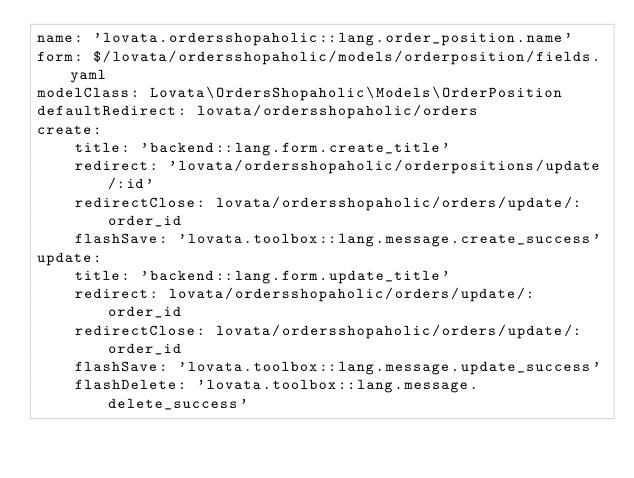Convert code to text. <code><loc_0><loc_0><loc_500><loc_500><_YAML_>name: 'lovata.ordersshopaholic::lang.order_position.name'
form: $/lovata/ordersshopaholic/models/orderposition/fields.yaml
modelClass: Lovata\OrdersShopaholic\Models\OrderPosition
defaultRedirect: lovata/ordersshopaholic/orders
create:
    title: 'backend::lang.form.create_title'
    redirect: 'lovata/ordersshopaholic/orderpositions/update/:id'
    redirectClose: lovata/ordersshopaholic/orders/update/:order_id
    flashSave: 'lovata.toolbox::lang.message.create_success'
update:
    title: 'backend::lang.form.update_title'
    redirect: lovata/ordersshopaholic/orders/update/:order_id
    redirectClose: lovata/ordersshopaholic/orders/update/:order_id
    flashSave: 'lovata.toolbox::lang.message.update_success'
    flashDelete: 'lovata.toolbox::lang.message.delete_success'
</code> 